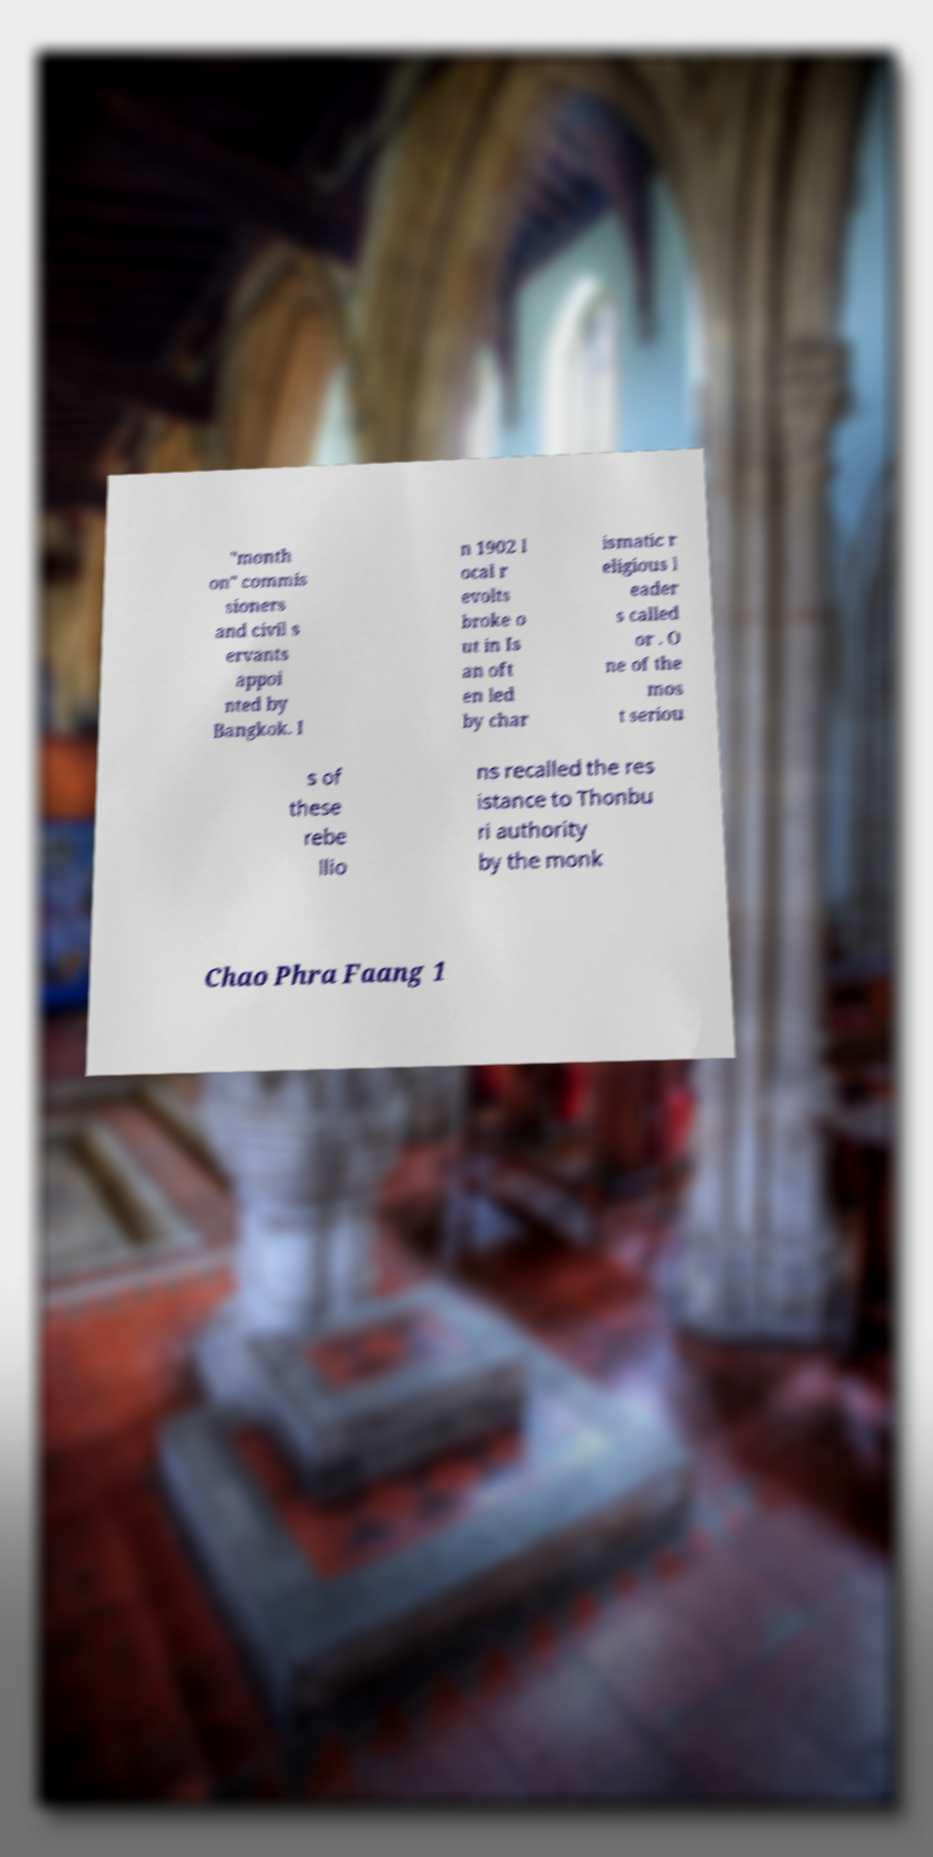Can you read and provide the text displayed in the image?This photo seems to have some interesting text. Can you extract and type it out for me? "month on" commis sioners and civil s ervants appoi nted by Bangkok. I n 1902 l ocal r evolts broke o ut in Is an oft en led by char ismatic r eligious l eader s called or . O ne of the mos t seriou s of these rebe llio ns recalled the res istance to Thonbu ri authority by the monk Chao Phra Faang 1 